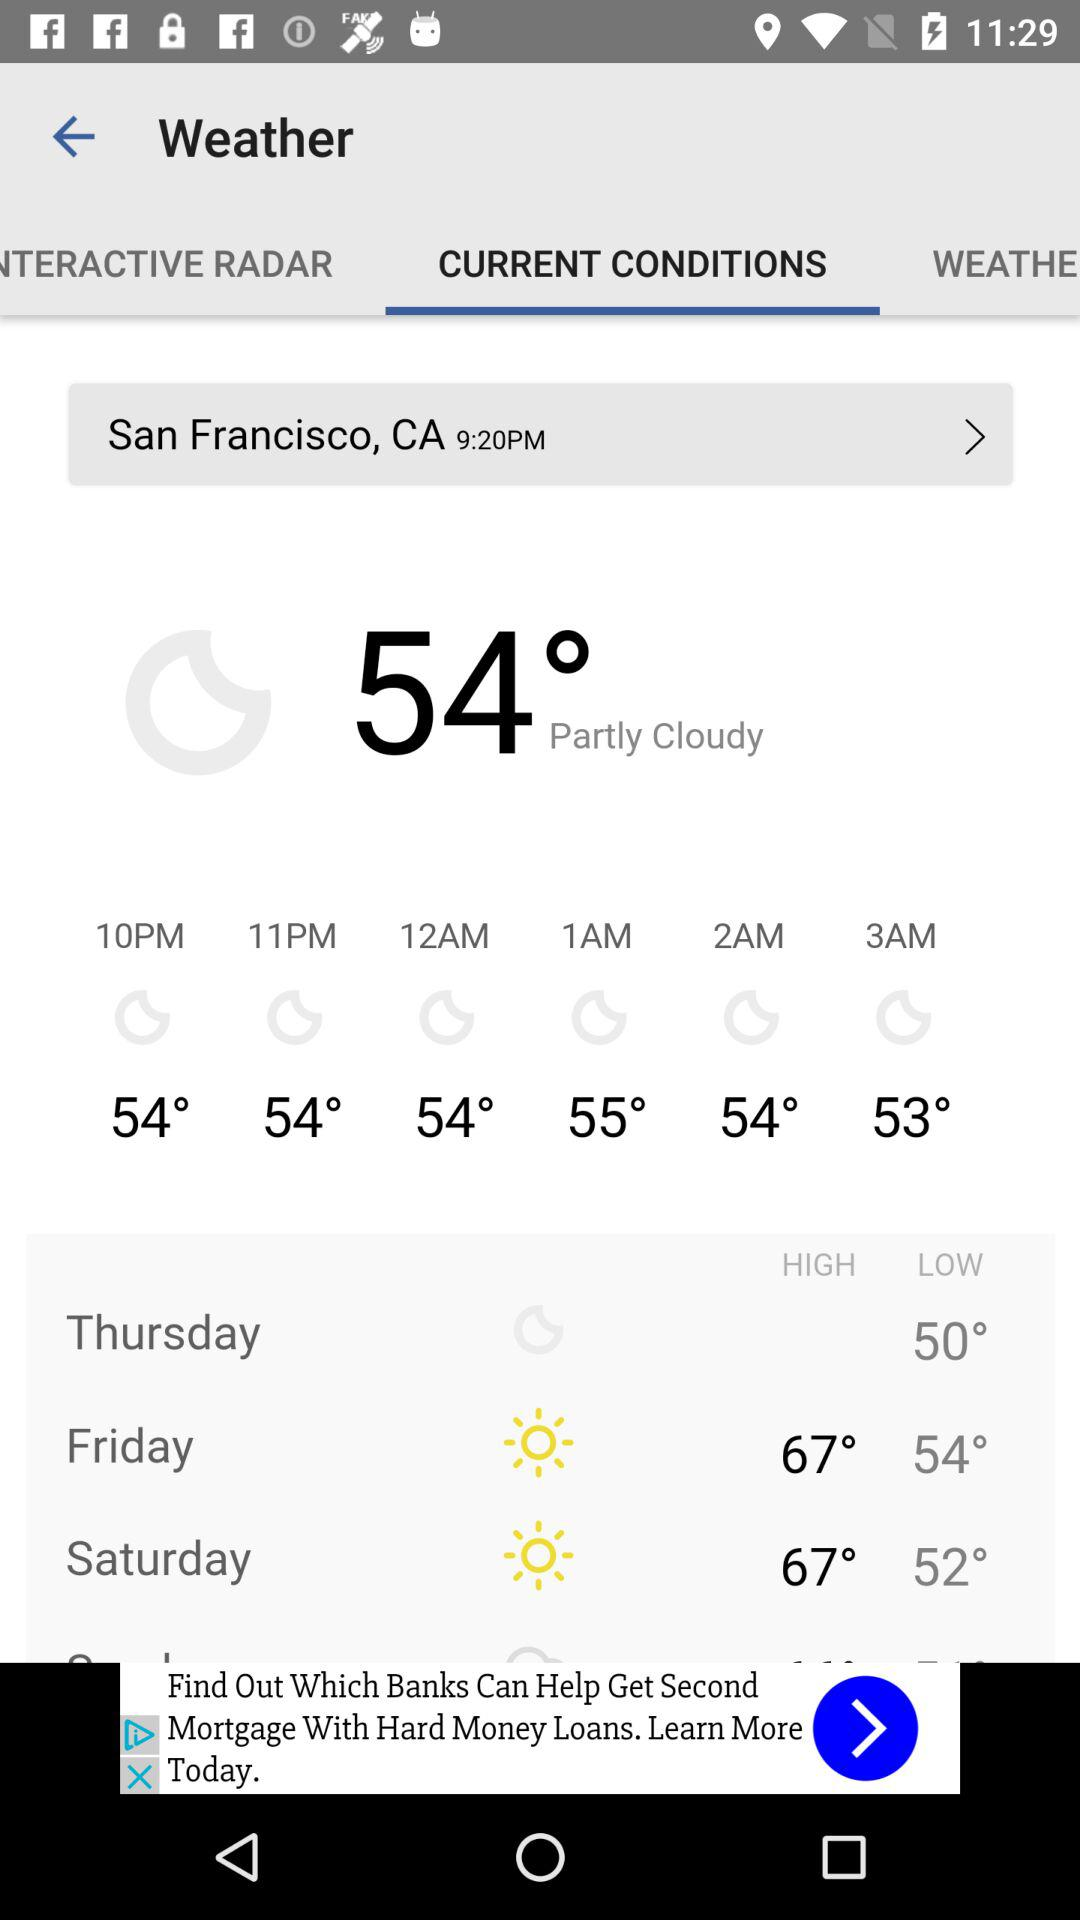How’s the weather on Thursday? The weather is "Partly Cloudy". 